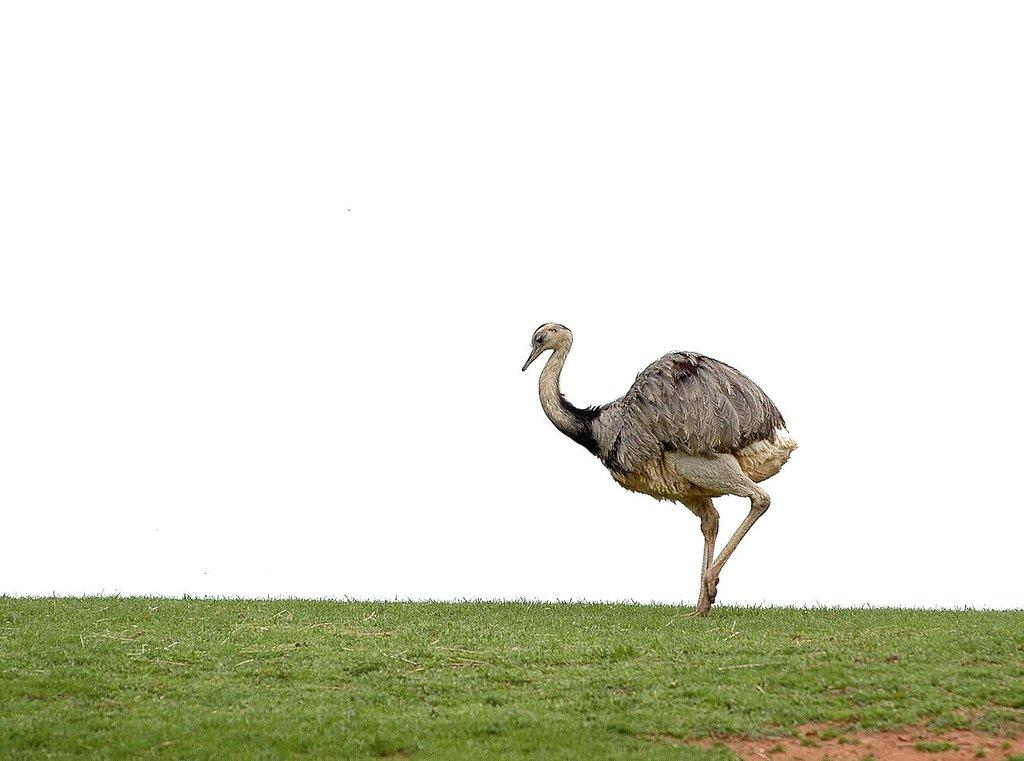What type of vegetation is visible in the image? There is grass in the image. What animal can be seen in the image? There is a bird in the middle of the image. How many bikes are present in the image? There are no bikes present in the image. What is the name of the daughter in the image? There is no daughter present in the image. 